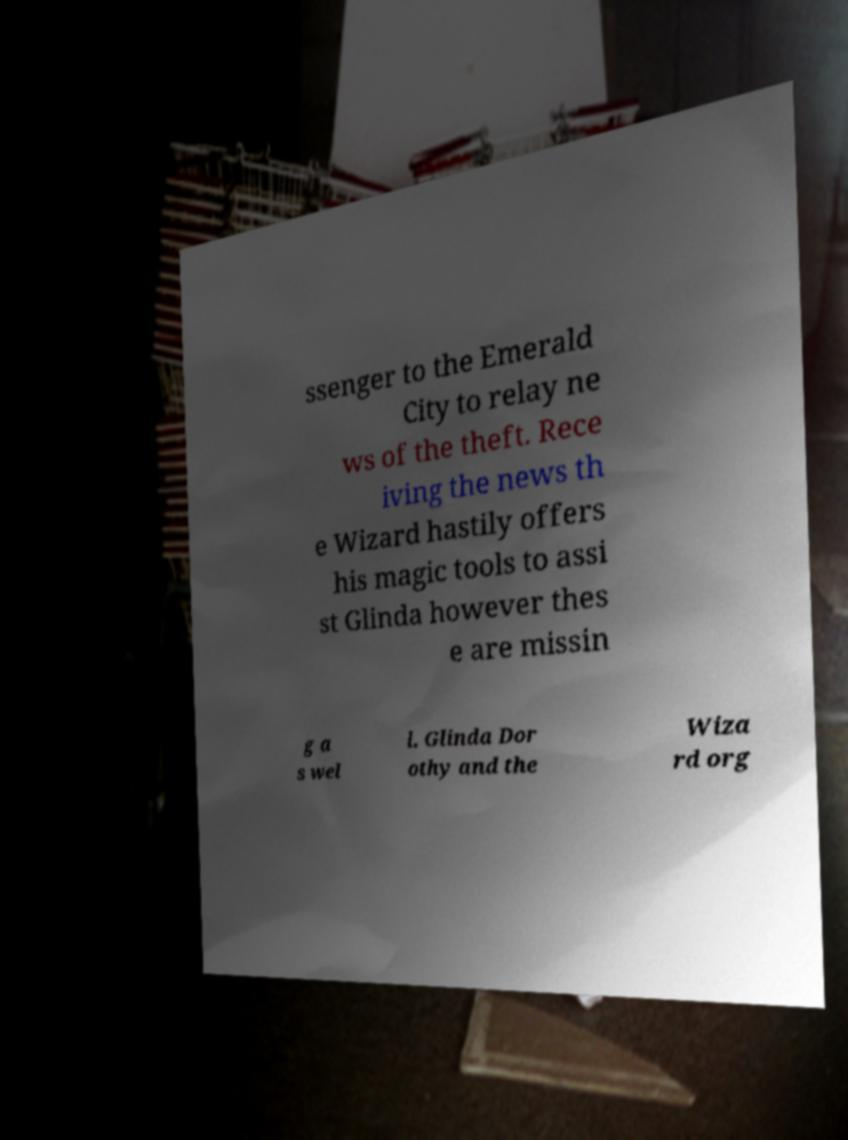I need the written content from this picture converted into text. Can you do that? ssenger to the Emerald City to relay ne ws of the theft. Rece iving the news th e Wizard hastily offers his magic tools to assi st Glinda however thes e are missin g a s wel l. Glinda Dor othy and the Wiza rd org 